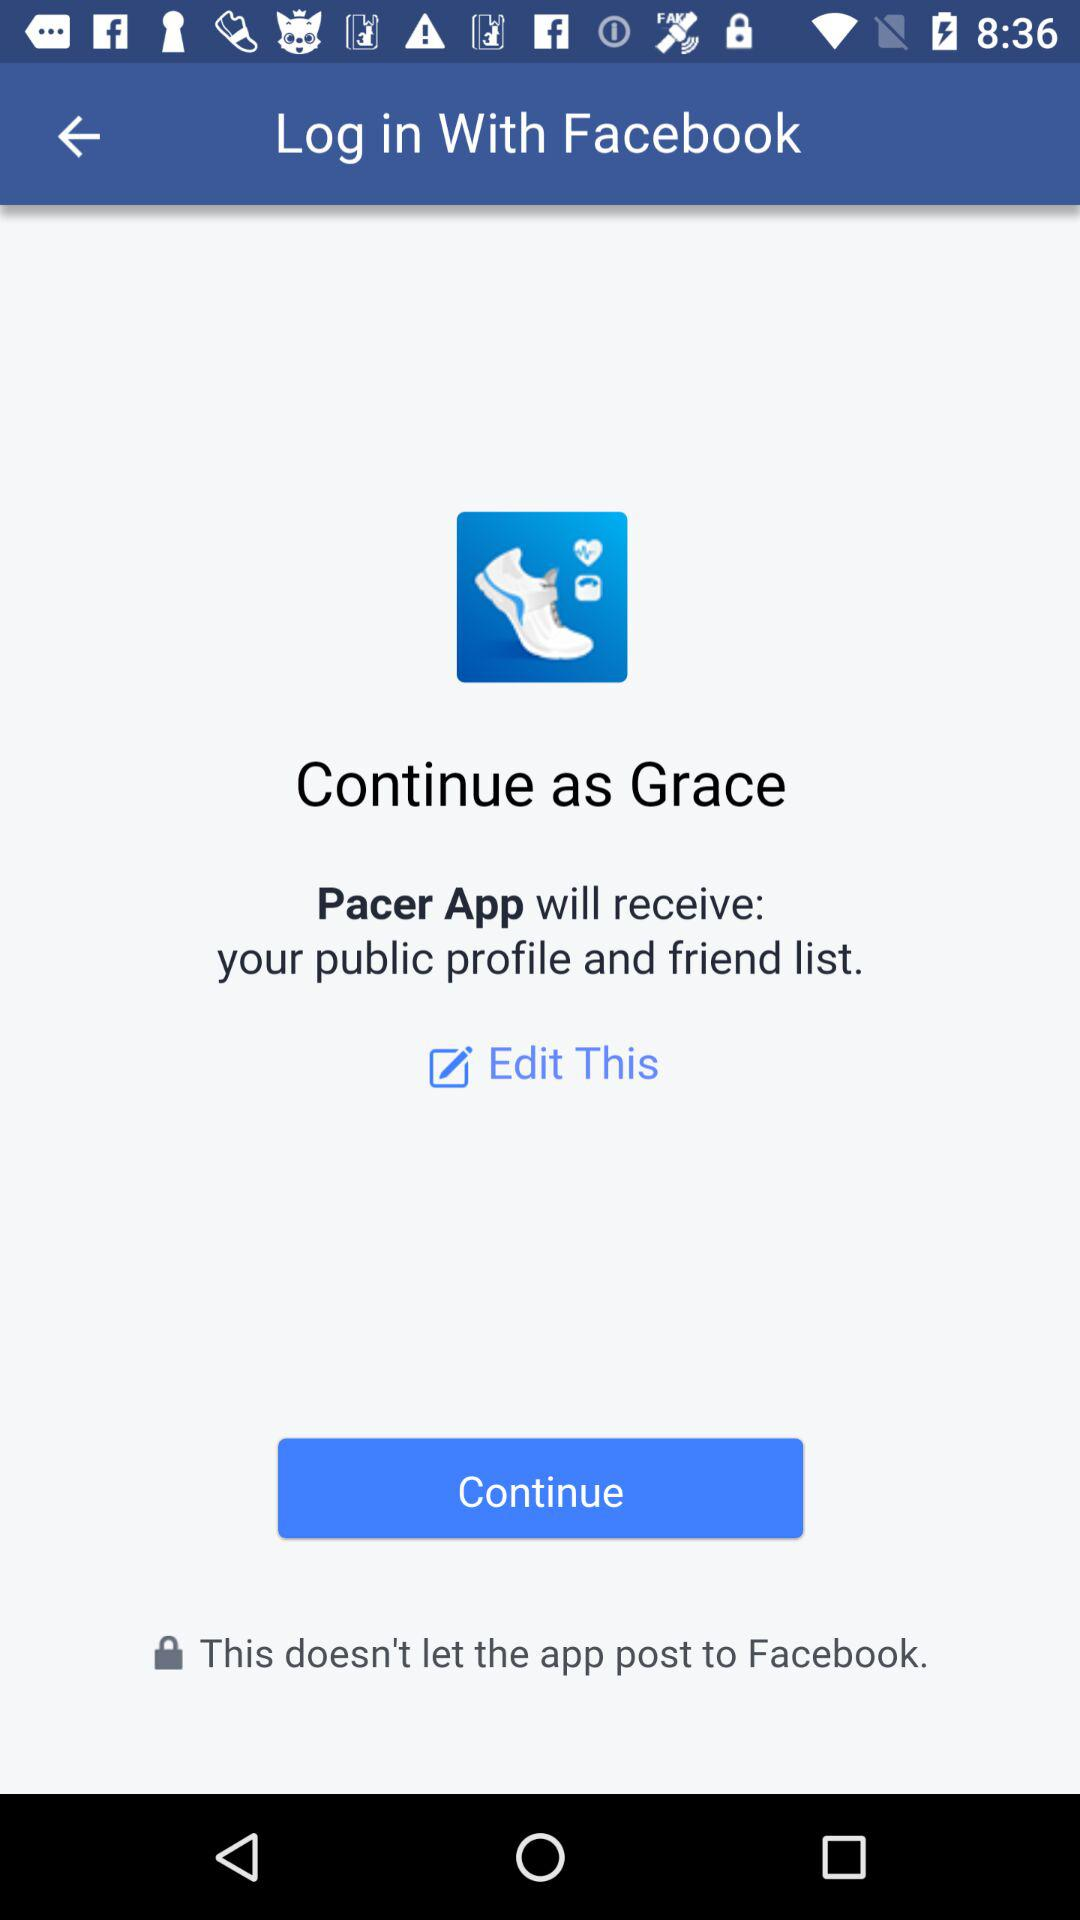What is the name of the user? The name of the user is Grace. 